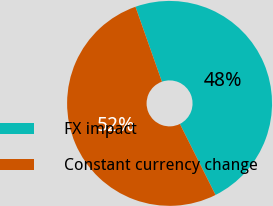Convert chart. <chart><loc_0><loc_0><loc_500><loc_500><pie_chart><fcel>FX impact<fcel>Constant currency change<nl><fcel>48.0%<fcel>52.0%<nl></chart> 